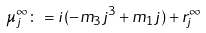<formula> <loc_0><loc_0><loc_500><loc_500>\mu _ { j } ^ { \infty } \colon = i ( - m _ { 3 } j ^ { 3 } + m _ { 1 } j ) + r _ { j } ^ { \infty }</formula> 